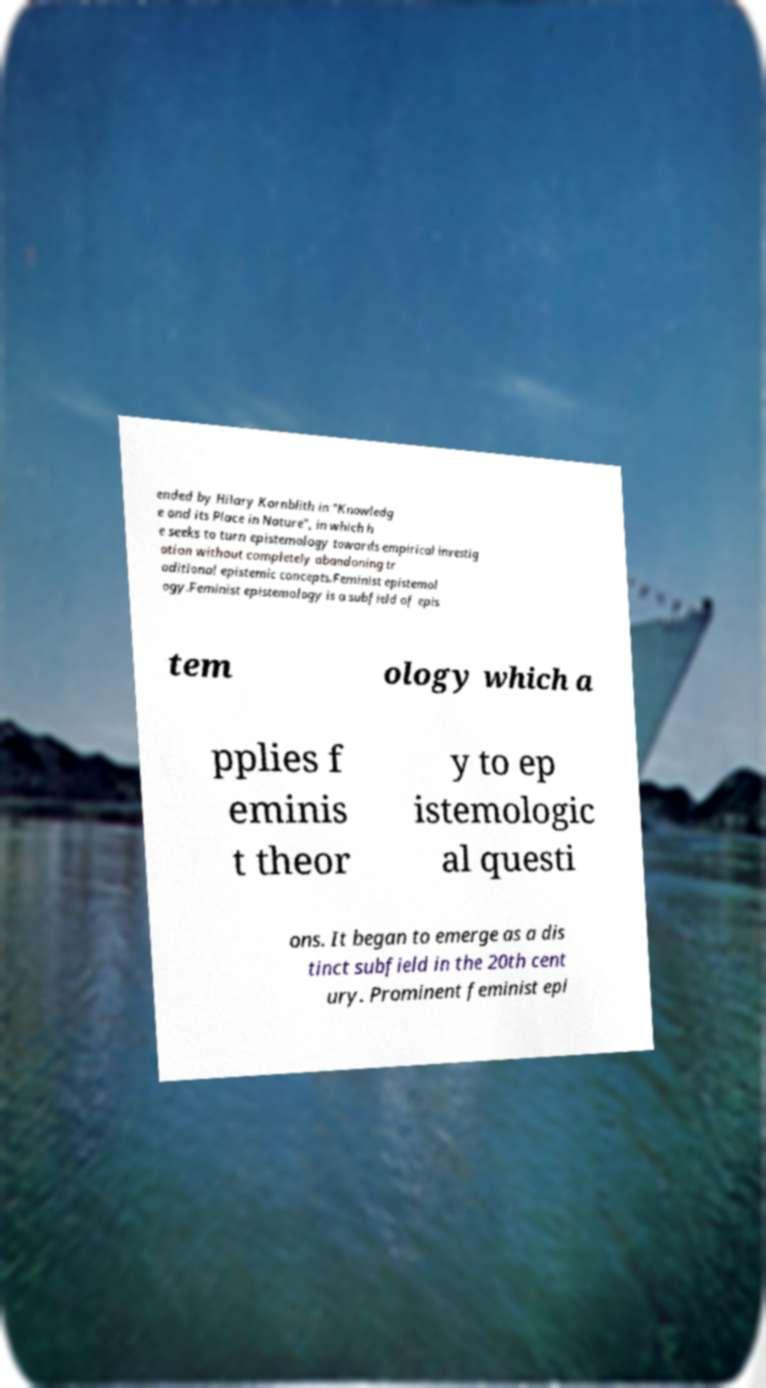Please identify and transcribe the text found in this image. ended by Hilary Kornblith in "Knowledg e and its Place in Nature", in which h e seeks to turn epistemology towards empirical investig ation without completely abandoning tr aditional epistemic concepts.Feminist epistemol ogy.Feminist epistemology is a subfield of epis tem ology which a pplies f eminis t theor y to ep istemologic al questi ons. It began to emerge as a dis tinct subfield in the 20th cent ury. Prominent feminist epi 